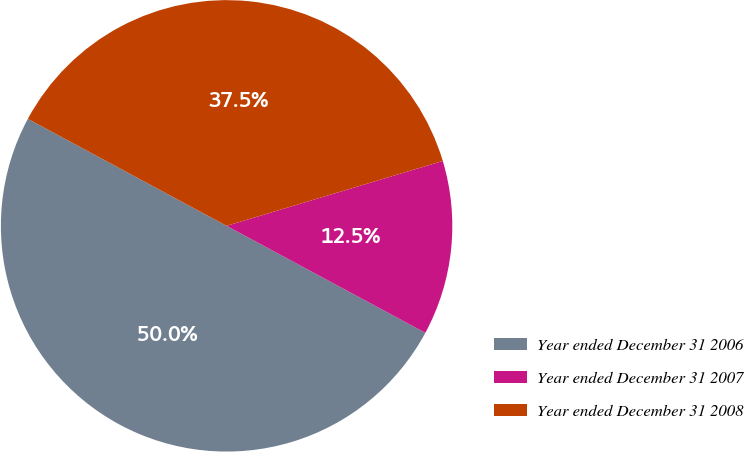<chart> <loc_0><loc_0><loc_500><loc_500><pie_chart><fcel>Year ended December 31 2006<fcel>Year ended December 31 2007<fcel>Year ended December 31 2008<nl><fcel>50.0%<fcel>12.5%<fcel>37.5%<nl></chart> 